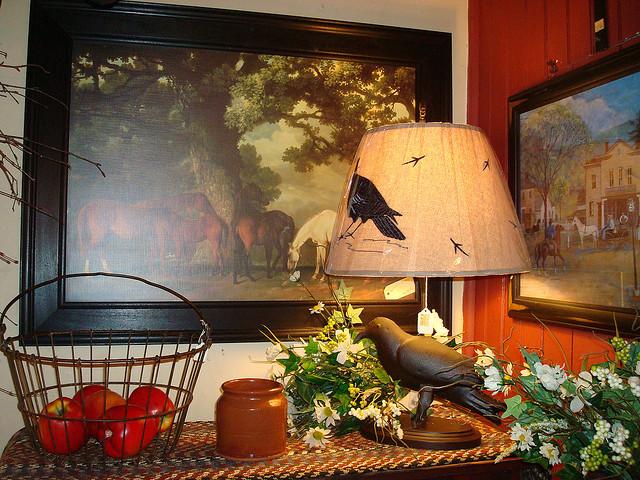How many pictures are in the picture?
Be succinct. 2. What is on the lampshade?
Answer briefly. Bird. What is in the basket?
Give a very brief answer. Apples. 